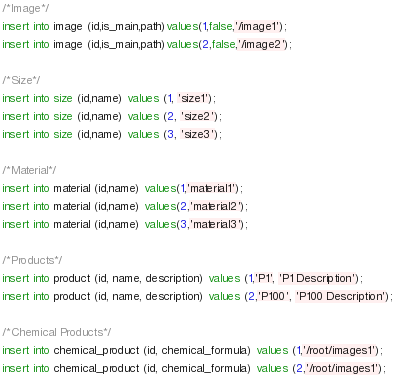<code> <loc_0><loc_0><loc_500><loc_500><_SQL_>/*Image*/
insert into image (id,is_main,path)values(1,false,'/image1');
insert into image (id,is_main,path)values(2,false,'/image2');

/*Size*/
insert into size (id,name) values (1, 'size1');
insert into size (id,name) values (2, 'size2');
insert into size (id,name) values (3, 'size3');

/*Material*/
insert into material (id,name) values(1,'material1');
insert into material (id,name) values(2,'material2');
insert into material (id,name) values(3,'material3');

/*Products*/
insert into product (id, name, description) values (1,'P1', 'P1 Description');
insert into product (id, name, description) values (2,'P100', 'P100 Description');

/*Chemical Products*/
insert into chemical_product (id, chemical_formula) values (1,'/root/images1');
insert into chemical_product (id, chemical_formula) values (2,'/root/images1');

</code> 